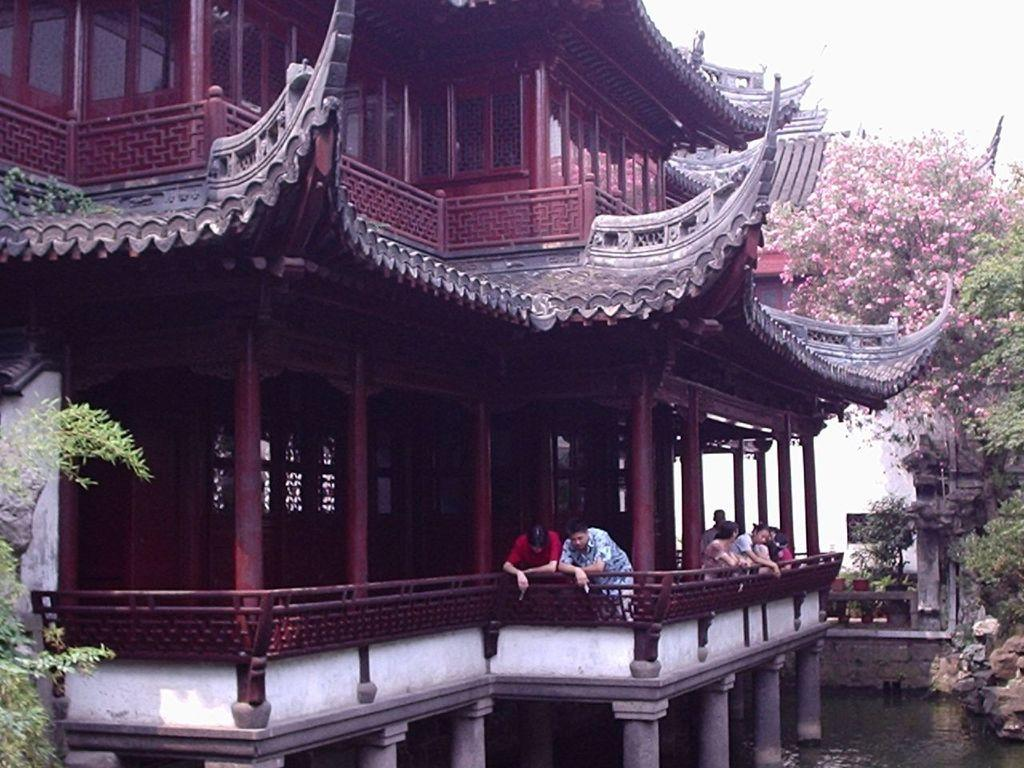What type of structures can be seen in the image? There are buildings in the image. Can you describe the people in the image? There is a group of people in the image. What type of vegetation is present in the image? There are trees in the image. What natural element can be seen in the image? There is water visible in the image. What type of flora is present in the image? There are flowers in the image. Where is the cannon located in the image? There is no cannon present in the image. What color is the thing on the left side of the image? There is no specific "thing" mentioned in the image, so we cannot answer this question. How many oranges are visible in the image? There are no oranges present in the image. 